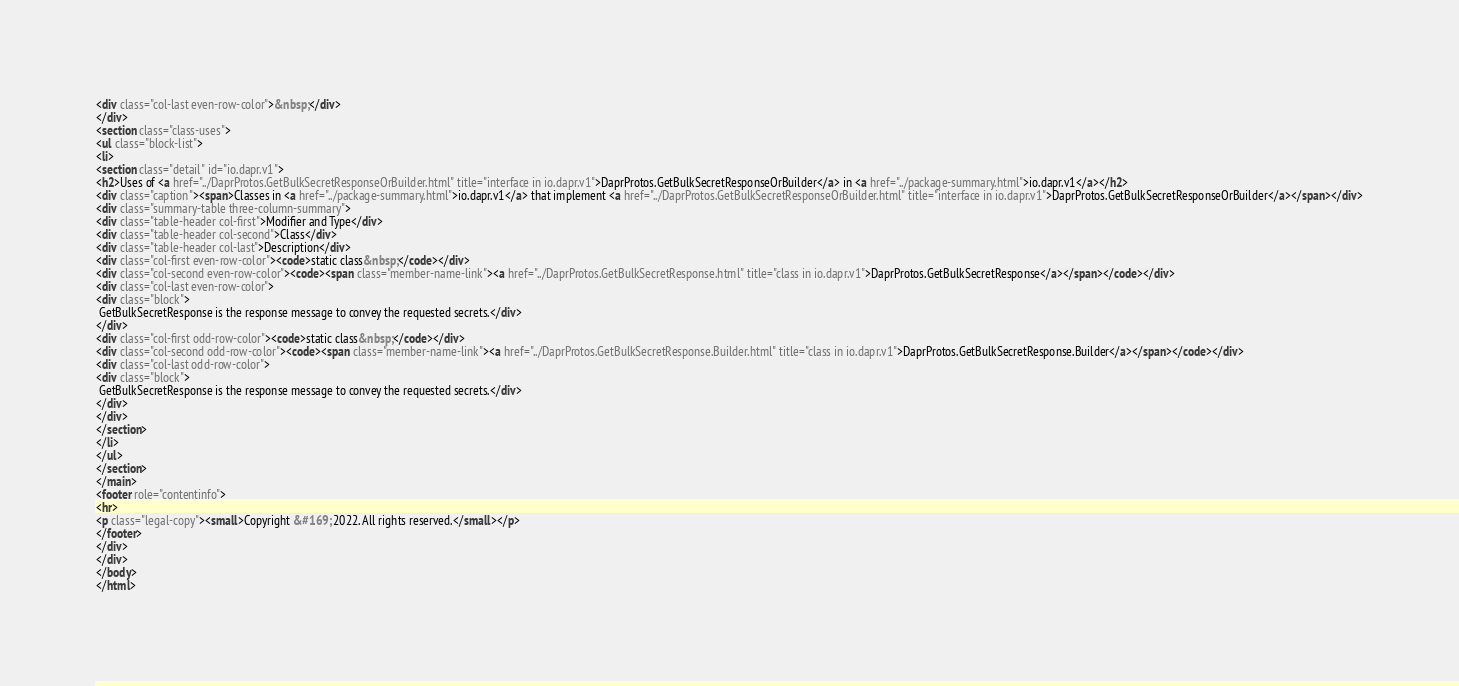<code> <loc_0><loc_0><loc_500><loc_500><_HTML_><div class="col-last even-row-color">&nbsp;</div>
</div>
<section class="class-uses">
<ul class="block-list">
<li>
<section class="detail" id="io.dapr.v1">
<h2>Uses of <a href="../DaprProtos.GetBulkSecretResponseOrBuilder.html" title="interface in io.dapr.v1">DaprProtos.GetBulkSecretResponseOrBuilder</a> in <a href="../package-summary.html">io.dapr.v1</a></h2>
<div class="caption"><span>Classes in <a href="../package-summary.html">io.dapr.v1</a> that implement <a href="../DaprProtos.GetBulkSecretResponseOrBuilder.html" title="interface in io.dapr.v1">DaprProtos.GetBulkSecretResponseOrBuilder</a></span></div>
<div class="summary-table three-column-summary">
<div class="table-header col-first">Modifier and Type</div>
<div class="table-header col-second">Class</div>
<div class="table-header col-last">Description</div>
<div class="col-first even-row-color"><code>static class&nbsp;</code></div>
<div class="col-second even-row-color"><code><span class="member-name-link"><a href="../DaprProtos.GetBulkSecretResponse.html" title="class in io.dapr.v1">DaprProtos.GetBulkSecretResponse</a></span></code></div>
<div class="col-last even-row-color">
<div class="block">
 GetBulkSecretResponse is the response message to convey the requested secrets.</div>
</div>
<div class="col-first odd-row-color"><code>static class&nbsp;</code></div>
<div class="col-second odd-row-color"><code><span class="member-name-link"><a href="../DaprProtos.GetBulkSecretResponse.Builder.html" title="class in io.dapr.v1">DaprProtos.GetBulkSecretResponse.Builder</a></span></code></div>
<div class="col-last odd-row-color">
<div class="block">
 GetBulkSecretResponse is the response message to convey the requested secrets.</div>
</div>
</div>
</section>
</li>
</ul>
</section>
</main>
<footer role="contentinfo">
<hr>
<p class="legal-copy"><small>Copyright &#169; 2022. All rights reserved.</small></p>
</footer>
</div>
</div>
</body>
</html>
</code> 